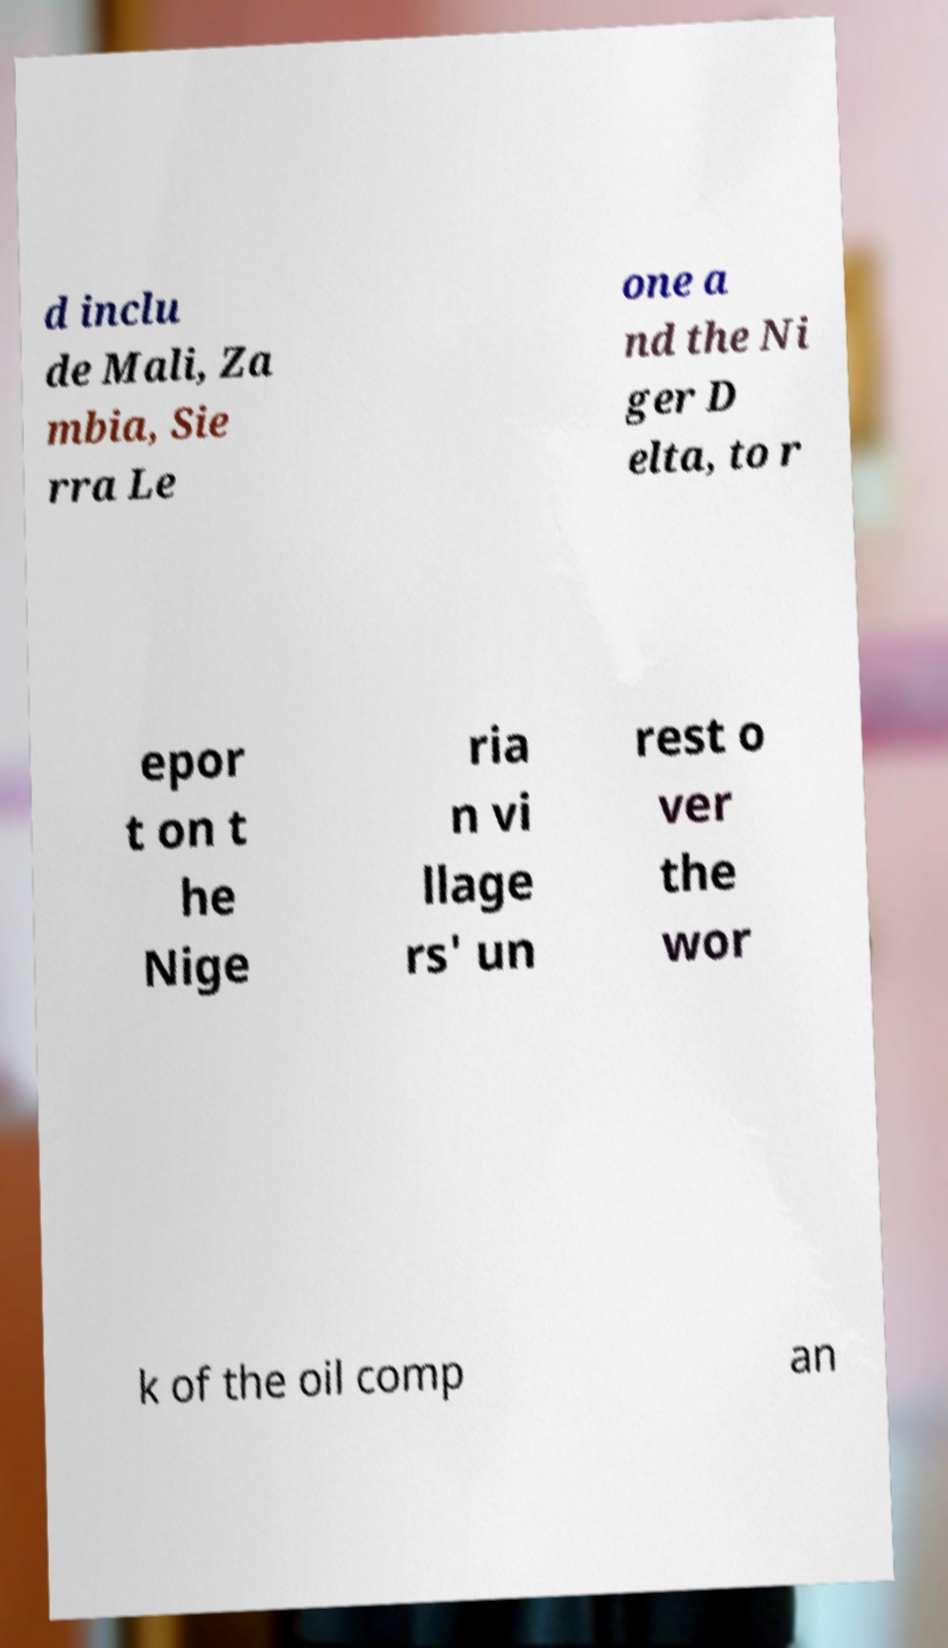What messages or text are displayed in this image? I need them in a readable, typed format. d inclu de Mali, Za mbia, Sie rra Le one a nd the Ni ger D elta, to r epor t on t he Nige ria n vi llage rs' un rest o ver the wor k of the oil comp an 